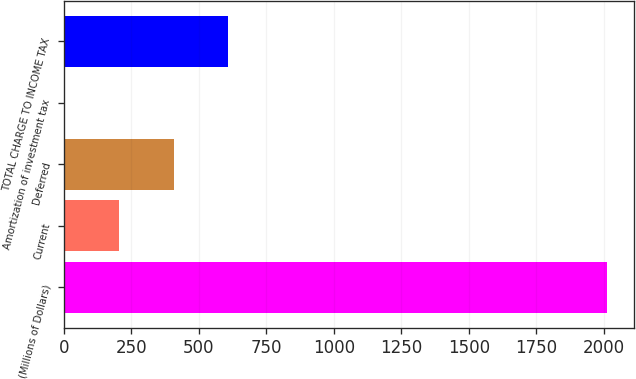Convert chart. <chart><loc_0><loc_0><loc_500><loc_500><bar_chart><fcel>(Millions of Dollars)<fcel>Current<fcel>Deferred<fcel>Amortization of investment tax<fcel>TOTAL CHARGE TO INCOME TAX<nl><fcel>2011<fcel>206.5<fcel>407<fcel>6<fcel>607.5<nl></chart> 